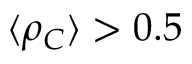<formula> <loc_0><loc_0><loc_500><loc_500>\langle \rho _ { C } \rangle > 0 . 5</formula> 